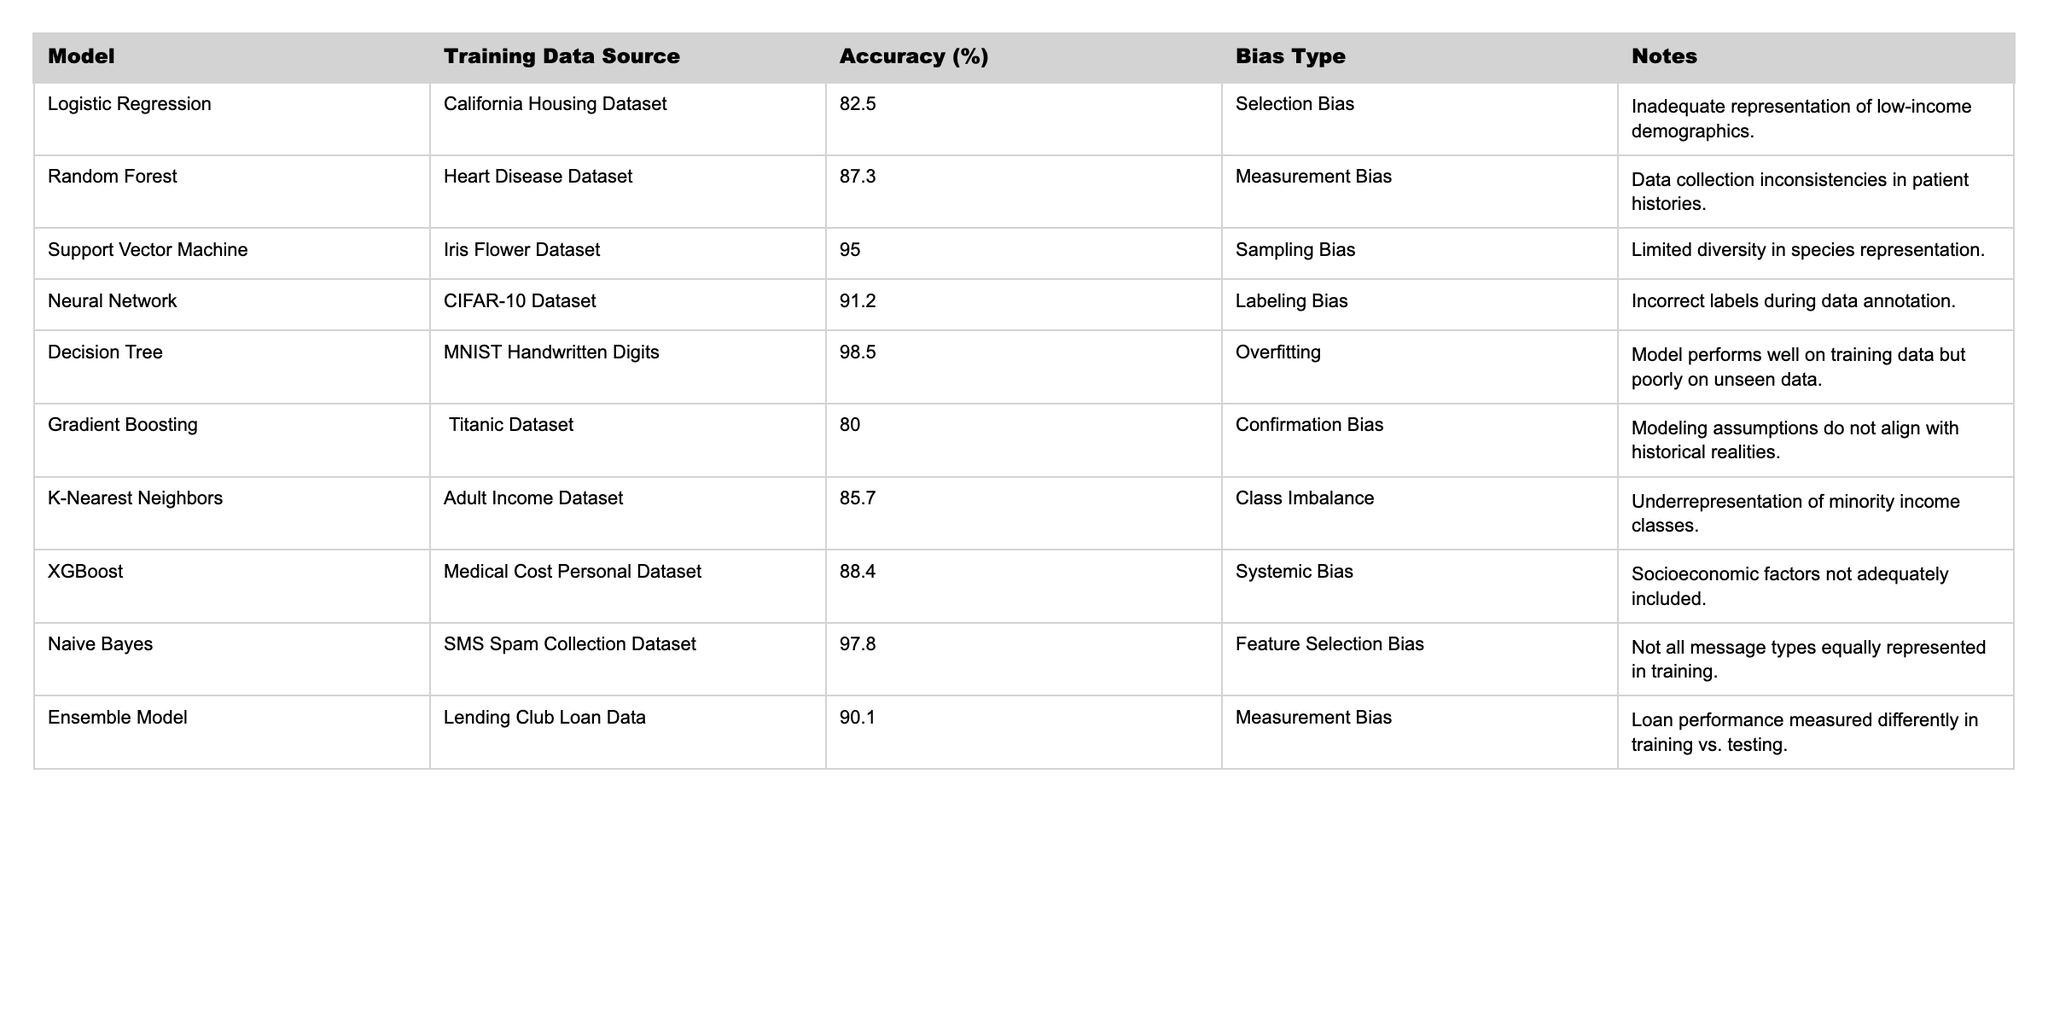What is the accuracy of the Neural Network model? The table lists the Neural Network model's accuracy under the 'Accuracy (%)' column, which is 91.2%.
Answer: 91.2% Which model shows the highest accuracy? Looking at the 'Accuracy (%)' column, the Decision Tree model has the highest accuracy of 98.5%.
Answer: 98.5% What type of bias is associated with the Random Forest model? The table indicates that the Random Forest model has a 'Measurement Bias'.
Answer: Measurement Bias What is the average accuracy of the models mentioned in the table? To calculate the average accuracy, we first sum all accuracies: 82.5 + 87.3 + 95.0 + 91.2 + 98.5 + 80.0 + 85.7 + 88.4 + 97.8 + 90.1 = 906.5. There are 10 models, so the average accuracy is 906.5 / 10 = 90.65%.
Answer: 90.65% Which model has a systematic bias and what is its accuracy? The table shows that the XGBoost model has a 'Systemic Bias' with an accuracy of 88.4%.
Answer: 88.4% Is any model listed in the table free from bias? Upon reviewing the table, all models have some type of identified bias, therefore, no model is completely free from bias.
Answer: No What is the difference in accuracy between the Support Vector Machine and the Decision Tree models? The Support Vector Machine accuracy is 95.0%, and the Decision Tree accuracy is 98.5%. The difference is 98.5 - 95.0 = 3.5%.
Answer: 3.5% Which model has the lowest accuracy and what bias does it have? The Gradient Boosting model has the lowest accuracy of 80.0%, which is associated with 'Confirmation Bias'.
Answer: 80.0%, Confirmation Bias If we only consider models with labeling bias, what is the highest accuracy among them? The only model with labeling bias is the Neural Network at 91.2% and the accuracy is higher than that of any other models containing labeling bias.
Answer: 91.2% How many models indicated class imbalance as a type of bias? By scanning the 'Bias Type' column, we can see that the K-Nearest Neighbors model is the only one indicating 'Class Imbalance' as a bias type.
Answer: 1 